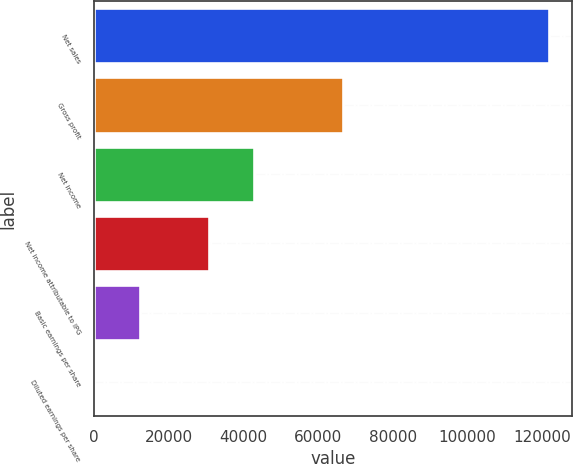Convert chart. <chart><loc_0><loc_0><loc_500><loc_500><bar_chart><fcel>Net sales<fcel>Gross profit<fcel>Net income<fcel>Net income attributable to IPG<fcel>Basic earnings per share<fcel>Diluted earnings per share<nl><fcel>121936<fcel>66706<fcel>42929.5<fcel>30736<fcel>12194.2<fcel>0.63<nl></chart> 